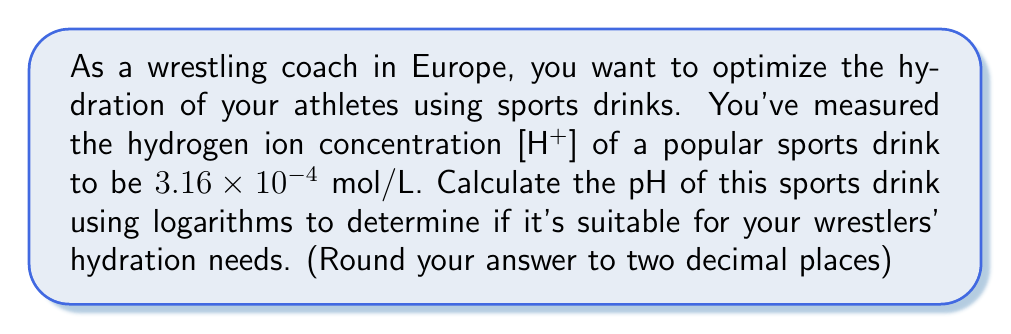Show me your answer to this math problem. To solve this problem, we'll use the definition of pH and logarithms:

1) The pH is defined as the negative logarithm (base 10) of the hydrogen ion concentration:

   $$ pH = -\log_{10}[H^+] $$

2) We're given that [H+] = 3.16 × 10^-4 mol/L

3) Substituting this into our equation:

   $$ pH = -\log_{10}(3.16 \times 10^{-4}) $$

4) Using the properties of logarithms, we can split this into two parts:

   $$ pH = -(\log_{10}(3.16) + \log_{10}(10^{-4})) $$

5) Simplify:
   
   $$ pH = -(\log_{10}(3.16) - 4) $$

6) Calculate $\log_{10}(3.16)$ using a calculator: 
   
   $\log_{10}(3.16) \approx 0.4997$

7) Substitute and calculate:

   $$ pH = -(0.4997 - 4) = 3.5003 $$

8) Rounding to two decimal places:

   $$ pH \approx 3.50 $$

This pH level is quite acidic, which might not be ideal for optimal hydration. Most sports drinks have a pH between 3 and 4 to balance taste and tooth enamel protection.
Answer: The pH of the sports drink is approximately 3.50. 